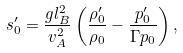Convert formula to latex. <formula><loc_0><loc_0><loc_500><loc_500>s _ { 0 } ^ { \prime } = \frac { g l _ { B } ^ { 2 } } { v _ { A } ^ { 2 } } \left ( \frac { \rho _ { 0 } ^ { \prime } } { \rho _ { 0 } } - \frac { p _ { 0 } ^ { \prime } } { \Gamma p _ { 0 } } \right ) ,</formula> 